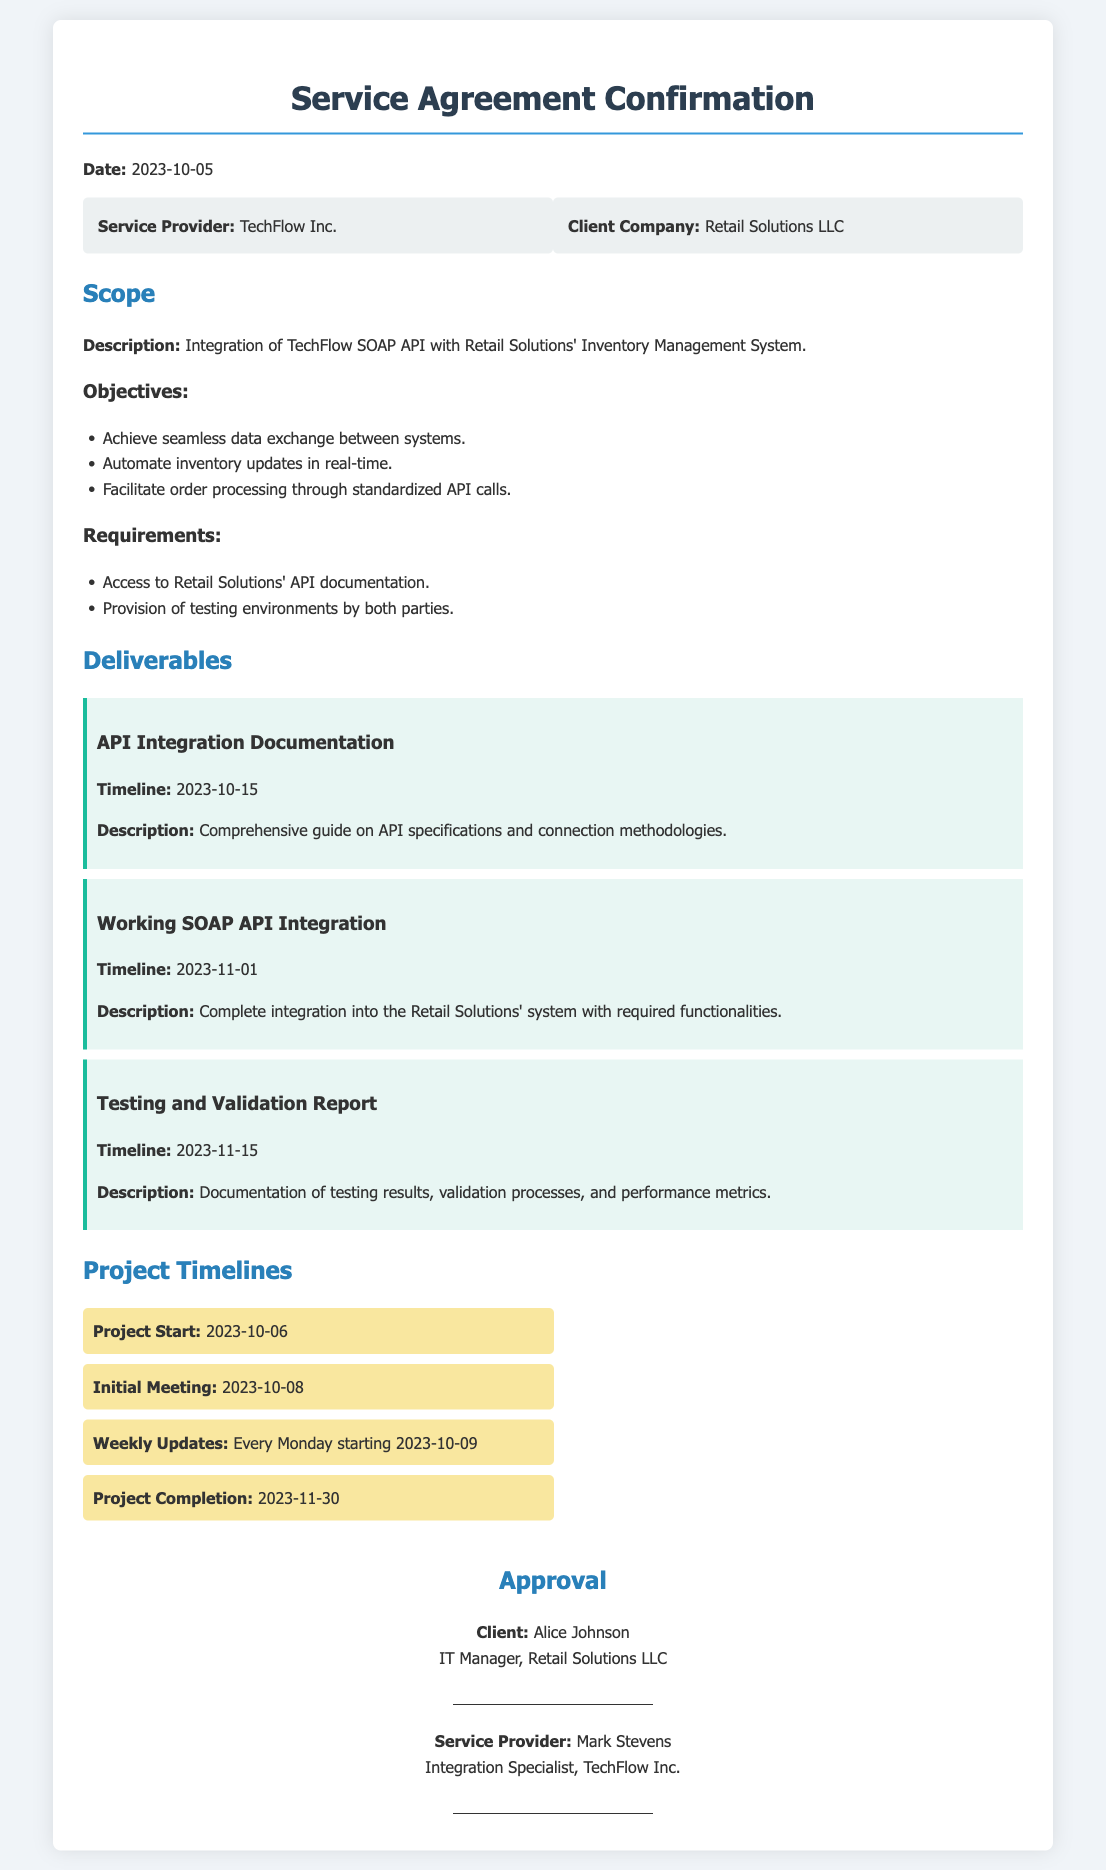What is the date of the service agreement confirmation? The date of the service agreement confirmation is directly stated in the document.
Answer: 2023-10-05 Who is the service provider? The name of the service provider is listed in the document under the parties section.
Answer: TechFlow Inc What is the first deliverable? The first deliverable is mentioned in the section detailing deliverables in the document.
Answer: API Integration Documentation What is the completion date of the project? The project completion date is specified in the project timelines section of the document.
Answer: 2023-11-30 What is the automation objective of the integration? This objective can be found in the scope section of the document, detailing the goals of the project.
Answer: Automate inventory updates in real-time Who will have the initial meeting and when? The document mentions the initial meeting with a specific date, providing both parts of information.
Answer: 2023-10-08 What is required from both parties for the project? The requirements for the project are explicitly outlined in the scope section.
Answer: Provision of testing environments by both parties What title does the client representative have? The document explicitly lists the title of the client representative involved in the agreement.
Answer: IT Manager What is the timeline for the testing and validation report? The timeline for the deliverable is explicitly stated in the deliverables section.
Answer: 2023-11-15 